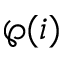Convert formula to latex. <formula><loc_0><loc_0><loc_500><loc_500>\wp ( i )</formula> 